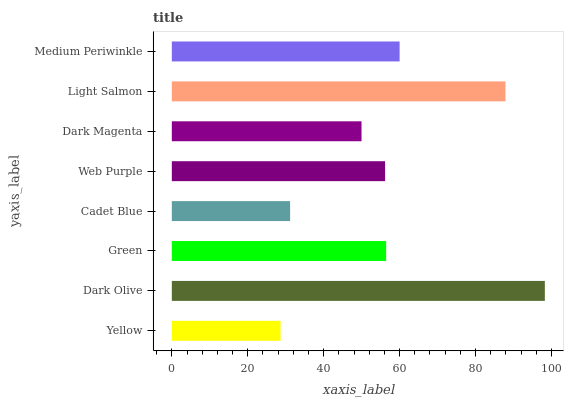Is Yellow the minimum?
Answer yes or no. Yes. Is Dark Olive the maximum?
Answer yes or no. Yes. Is Green the minimum?
Answer yes or no. No. Is Green the maximum?
Answer yes or no. No. Is Dark Olive greater than Green?
Answer yes or no. Yes. Is Green less than Dark Olive?
Answer yes or no. Yes. Is Green greater than Dark Olive?
Answer yes or no. No. Is Dark Olive less than Green?
Answer yes or no. No. Is Green the high median?
Answer yes or no. Yes. Is Web Purple the low median?
Answer yes or no. Yes. Is Yellow the high median?
Answer yes or no. No. Is Medium Periwinkle the low median?
Answer yes or no. No. 